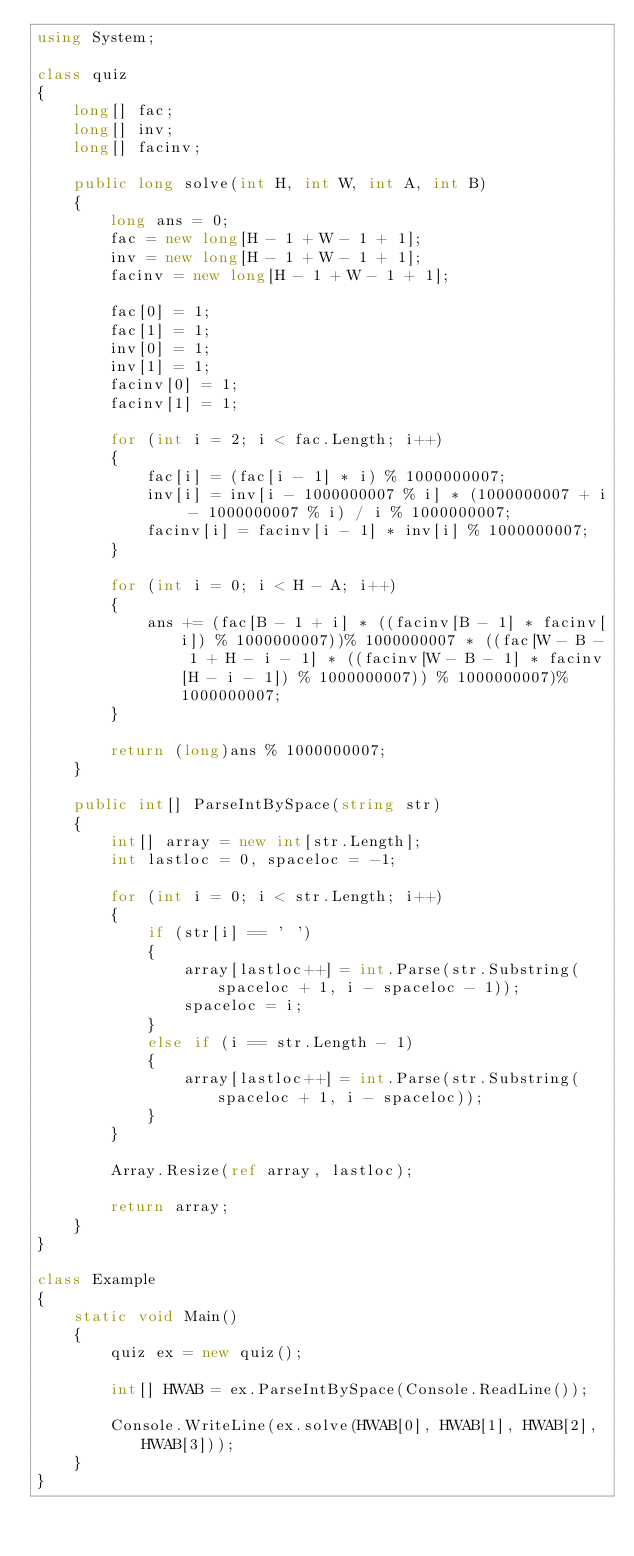Convert code to text. <code><loc_0><loc_0><loc_500><loc_500><_C#_>using System;

class quiz
{
    long[] fac;
    long[] inv;
    long[] facinv;

    public long solve(int H, int W, int A, int B)
    {
        long ans = 0;
        fac = new long[H - 1 + W - 1 + 1];
        inv = new long[H - 1 + W - 1 + 1];
        facinv = new long[H - 1 + W - 1 + 1];
        
        fac[0] = 1;
        fac[1] = 1;
        inv[0] = 1;
        inv[1] = 1;
        facinv[0] = 1;
        facinv[1] = 1;

        for (int i = 2; i < fac.Length; i++)
        {
            fac[i] = (fac[i - 1] * i) % 1000000007;
            inv[i] = inv[i - 1000000007 % i] * (1000000007 + i - 1000000007 % i) / i % 1000000007;
            facinv[i] = facinv[i - 1] * inv[i] % 1000000007;
        }

        for (int i = 0; i < H - A; i++)
        {
            ans += (fac[B - 1 + i] * ((facinv[B - 1] * facinv[i]) % 1000000007))% 1000000007 * ((fac[W - B - 1 + H - i - 1] * ((facinv[W - B - 1] * facinv[H - i - 1]) % 1000000007)) % 1000000007)% 1000000007;
        }

        return (long)ans % 1000000007;
    }

    public int[] ParseIntBySpace(string str)
    {
        int[] array = new int[str.Length];
        int lastloc = 0, spaceloc = -1;

        for (int i = 0; i < str.Length; i++)
        {
            if (str[i] == ' ')
            {
                array[lastloc++] = int.Parse(str.Substring(spaceloc + 1, i - spaceloc - 1));
                spaceloc = i;
            }
            else if (i == str.Length - 1)
            {
                array[lastloc++] = int.Parse(str.Substring(spaceloc + 1, i - spaceloc));
            }
        }

        Array.Resize(ref array, lastloc);

        return array;
    }
}

class Example
{
    static void Main()
    {
        quiz ex = new quiz();

        int[] HWAB = ex.ParseIntBySpace(Console.ReadLine());

        Console.WriteLine(ex.solve(HWAB[0], HWAB[1], HWAB[2], HWAB[3]));
    }
}</code> 